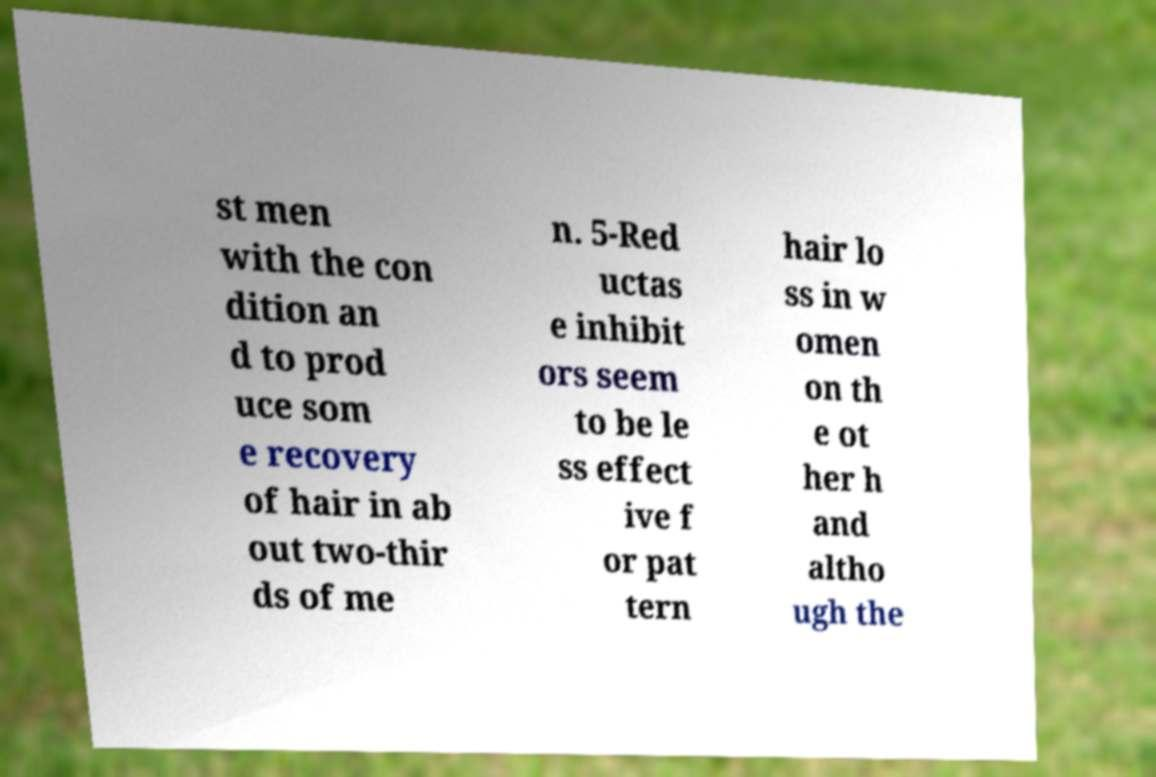For documentation purposes, I need the text within this image transcribed. Could you provide that? st men with the con dition an d to prod uce som e recovery of hair in ab out two-thir ds of me n. 5-Red uctas e inhibit ors seem to be le ss effect ive f or pat tern hair lo ss in w omen on th e ot her h and altho ugh the 